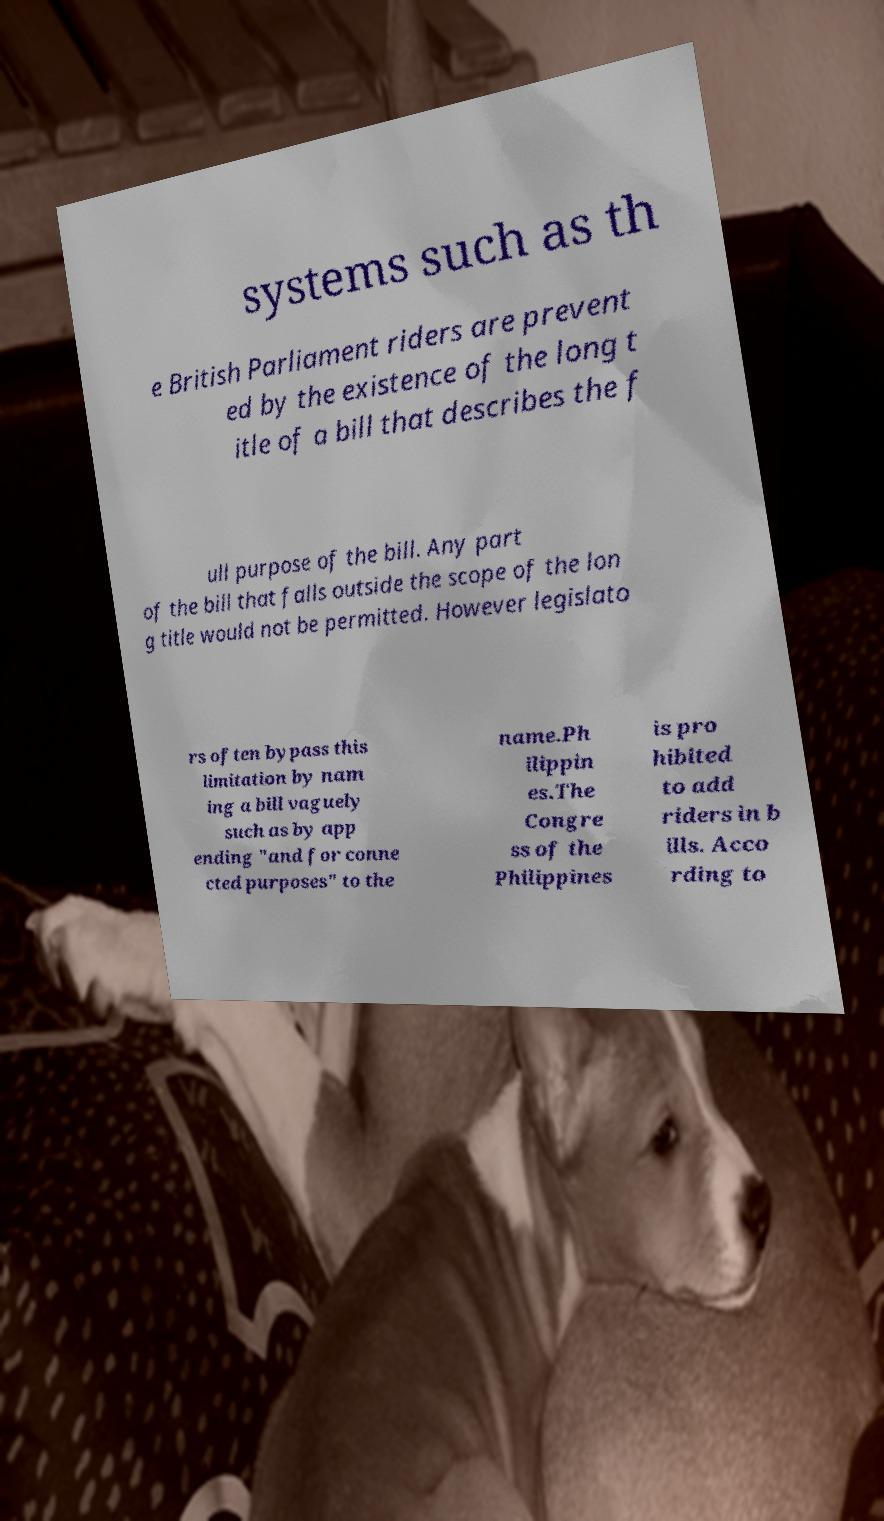Please read and relay the text visible in this image. What does it say? systems such as th e British Parliament riders are prevent ed by the existence of the long t itle of a bill that describes the f ull purpose of the bill. Any part of the bill that falls outside the scope of the lon g title would not be permitted. However legislato rs often bypass this limitation by nam ing a bill vaguely such as by app ending "and for conne cted purposes" to the name.Ph ilippin es.The Congre ss of the Philippines is pro hibited to add riders in b ills. Acco rding to 